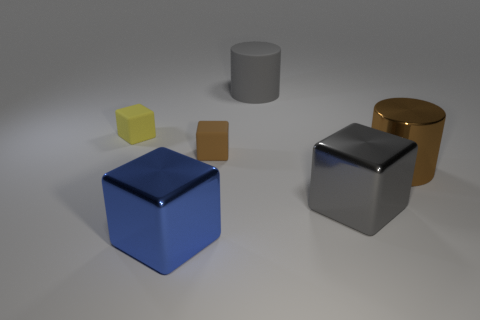Subtract all blue shiny blocks. How many blocks are left? 3 Add 1 gray cylinders. How many objects exist? 7 Subtract 1 cylinders. How many cylinders are left? 1 Subtract all blue cubes. How many cubes are left? 3 Subtract all brown cubes. Subtract all cyan spheres. How many cubes are left? 3 Subtract all large brown matte spheres. Subtract all big rubber things. How many objects are left? 5 Add 1 gray rubber cylinders. How many gray rubber cylinders are left? 2 Add 2 tiny red metallic cubes. How many tiny red metallic cubes exist? 2 Subtract 0 gray balls. How many objects are left? 6 Subtract all blocks. How many objects are left? 2 